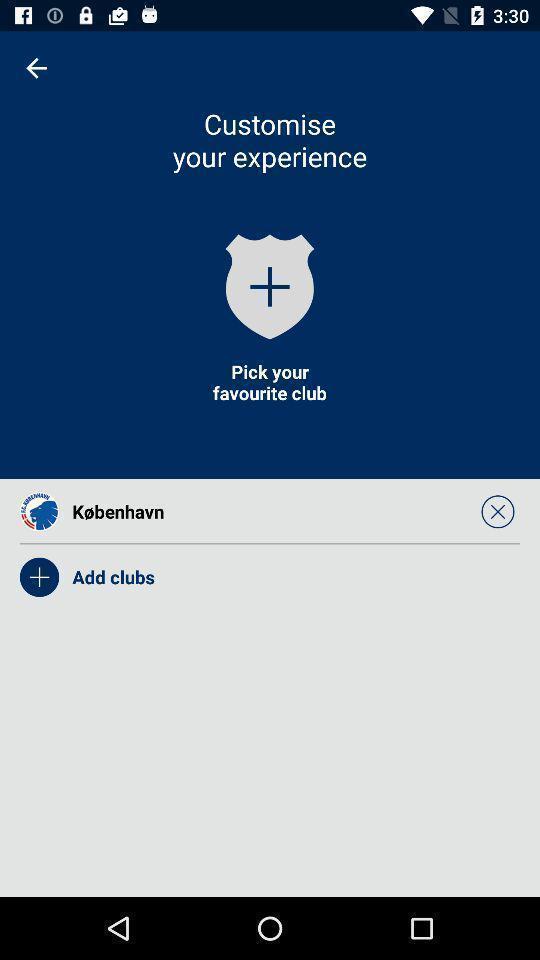Give me a summary of this screen capture. Page displaying the options to add club. 